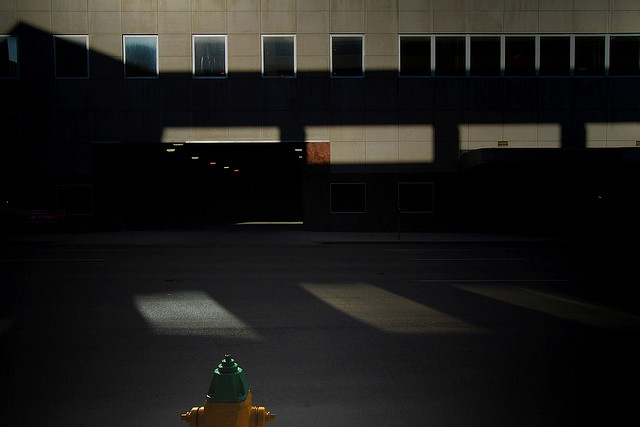Describe the objects in this image and their specific colors. I can see train in black and gray tones and fire hydrant in black, maroon, olive, and darkgreen tones in this image. 